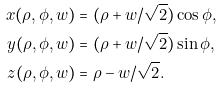Convert formula to latex. <formula><loc_0><loc_0><loc_500><loc_500>x ( \rho , \phi , w ) & = ( \rho + w / \sqrt { 2 } ) \cos \phi , \\ y ( \rho , \phi , w ) & = ( \rho + w / \sqrt { 2 } ) \sin \phi , \\ z ( \rho , \phi , w ) & = \rho - w / \sqrt { 2 } .</formula> 